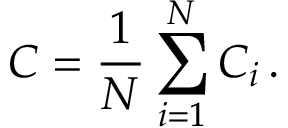<formula> <loc_0><loc_0><loc_500><loc_500>C = \frac { 1 } { N } \sum _ { i = 1 } ^ { N } C _ { i } \, .</formula> 